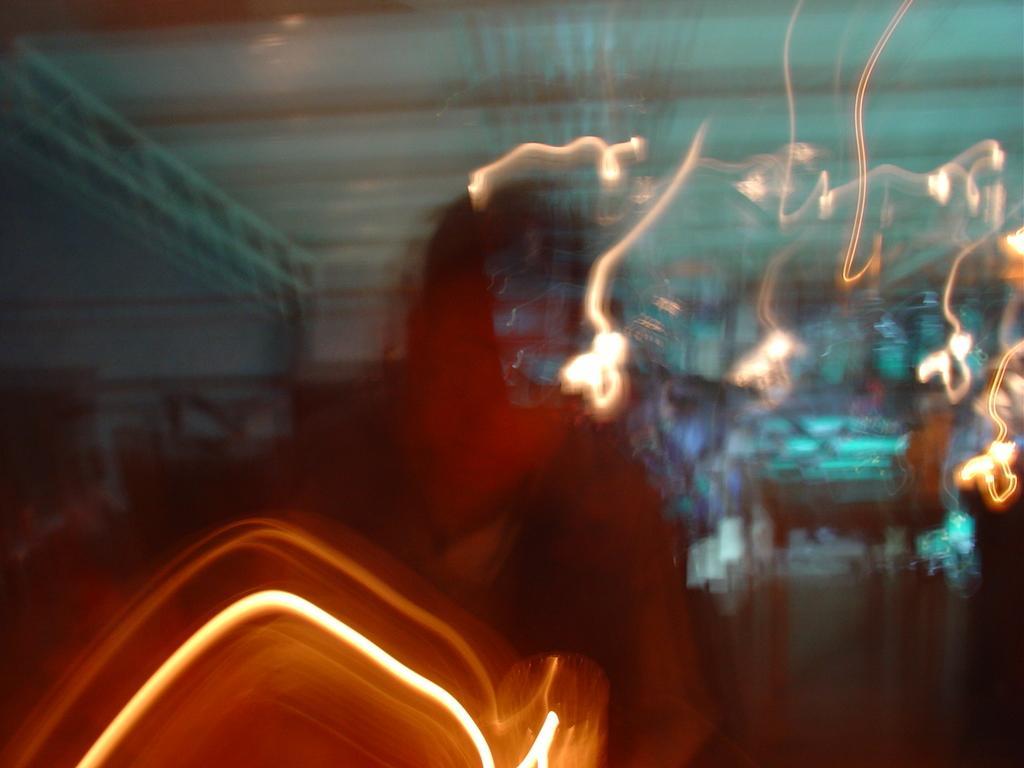In one or two sentences, can you explain what this image depicts? In this image I can see the blurred picture and I can see few multi color lights. 